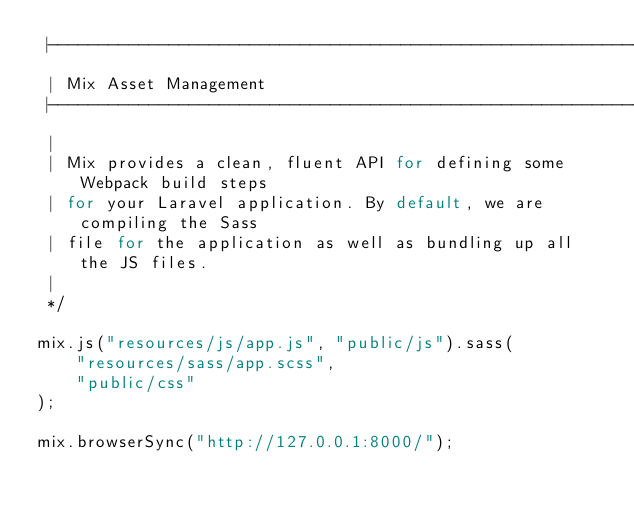Convert code to text. <code><loc_0><loc_0><loc_500><loc_500><_JavaScript_> |--------------------------------------------------------------------------
 | Mix Asset Management
 |--------------------------------------------------------------------------
 |
 | Mix provides a clean, fluent API for defining some Webpack build steps
 | for your Laravel application. By default, we are compiling the Sass
 | file for the application as well as bundling up all the JS files.
 |
 */

mix.js("resources/js/app.js", "public/js").sass(
    "resources/sass/app.scss",
    "public/css"
);

mix.browserSync("http://127.0.0.1:8000/");
</code> 